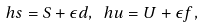<formula> <loc_0><loc_0><loc_500><loc_500>\ h { s } = S + \epsilon d , \ h { u } = U + \epsilon f ,</formula> 